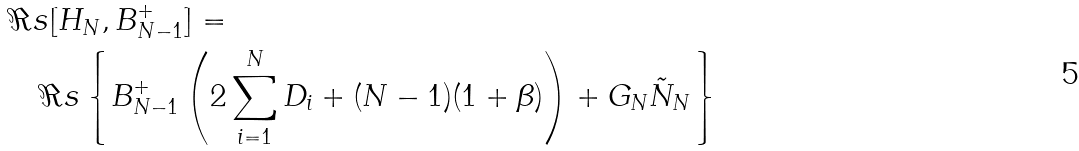Convert formula to latex. <formula><loc_0><loc_0><loc_500><loc_500>& \Re s [ H _ { N } , B _ { N - 1 } ^ { + } ] = \\ & \quad \Re s \left \{ B _ { N - 1 } ^ { + } \left ( 2 \sum _ { i = 1 } ^ { N } D _ { i } + ( N - 1 ) ( 1 + \beta ) \right ) + G _ { N } \tilde { N } _ { N } \right \}</formula> 